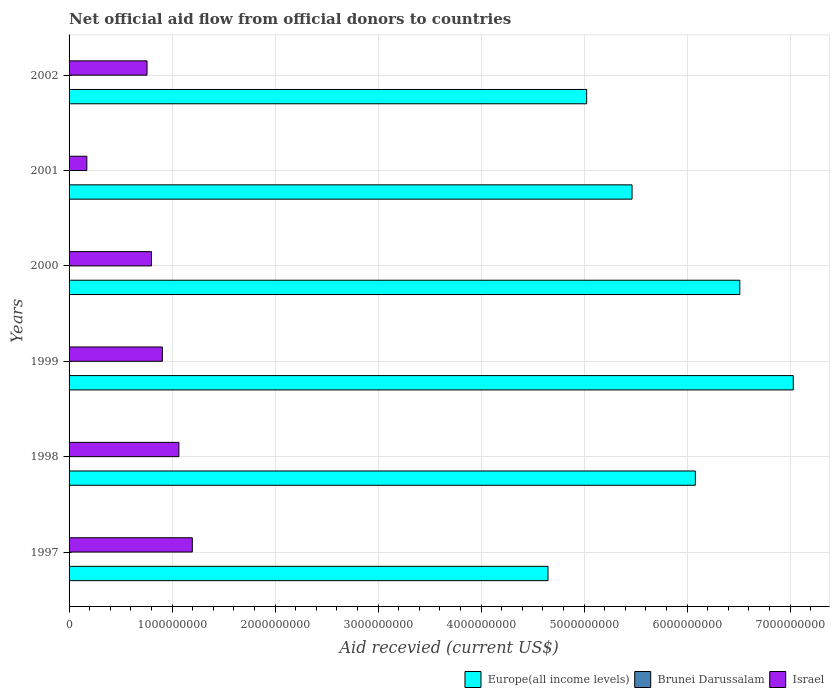How many different coloured bars are there?
Your response must be concise. 3. Are the number of bars per tick equal to the number of legend labels?
Ensure brevity in your answer.  No. Are the number of bars on each tick of the Y-axis equal?
Your answer should be very brief. No. How many bars are there on the 2nd tick from the top?
Your response must be concise. 3. What is the total aid received in Israel in 1999?
Offer a very short reply. 9.06e+08. Across all years, what is the maximum total aid received in Israel?
Make the answer very short. 1.20e+09. What is the total total aid received in Europe(all income levels) in the graph?
Offer a very short reply. 3.48e+1. What is the difference between the total aid received in Europe(all income levels) in 1997 and that in 1998?
Provide a succinct answer. -1.43e+09. What is the difference between the total aid received in Europe(all income levels) in 2000 and the total aid received in Brunei Darussalam in 1998?
Provide a short and direct response. 6.51e+09. What is the average total aid received in Europe(all income levels) per year?
Give a very brief answer. 5.79e+09. In the year 2002, what is the difference between the total aid received in Europe(all income levels) and total aid received in Israel?
Ensure brevity in your answer.  4.27e+09. What is the ratio of the total aid received in Israel in 2001 to that in 2002?
Provide a short and direct response. 0.23. Is the total aid received in Europe(all income levels) in 1998 less than that in 2002?
Ensure brevity in your answer.  No. What is the difference between the highest and the lowest total aid received in Europe(all income levels)?
Ensure brevity in your answer.  2.38e+09. Is it the case that in every year, the sum of the total aid received in Brunei Darussalam and total aid received in Europe(all income levels) is greater than the total aid received in Israel?
Keep it short and to the point. Yes. Are all the bars in the graph horizontal?
Your answer should be compact. Yes. How many years are there in the graph?
Keep it short and to the point. 6. Does the graph contain any zero values?
Make the answer very short. Yes. Where does the legend appear in the graph?
Keep it short and to the point. Bottom right. How many legend labels are there?
Keep it short and to the point. 3. What is the title of the graph?
Give a very brief answer. Net official aid flow from official donors to countries. Does "Romania" appear as one of the legend labels in the graph?
Give a very brief answer. No. What is the label or title of the X-axis?
Offer a very short reply. Aid recevied (current US$). What is the Aid recevied (current US$) in Europe(all income levels) in 1997?
Provide a succinct answer. 4.65e+09. What is the Aid recevied (current US$) of Brunei Darussalam in 1997?
Ensure brevity in your answer.  3.80e+05. What is the Aid recevied (current US$) in Israel in 1997?
Make the answer very short. 1.20e+09. What is the Aid recevied (current US$) of Europe(all income levels) in 1998?
Your answer should be very brief. 6.08e+09. What is the Aid recevied (current US$) of Brunei Darussalam in 1998?
Ensure brevity in your answer.  3.30e+05. What is the Aid recevied (current US$) of Israel in 1998?
Keep it short and to the point. 1.07e+09. What is the Aid recevied (current US$) of Europe(all income levels) in 1999?
Offer a very short reply. 7.03e+09. What is the Aid recevied (current US$) in Brunei Darussalam in 1999?
Your answer should be very brief. 1.43e+06. What is the Aid recevied (current US$) in Israel in 1999?
Provide a succinct answer. 9.06e+08. What is the Aid recevied (current US$) in Europe(all income levels) in 2000?
Offer a very short reply. 6.51e+09. What is the Aid recevied (current US$) in Brunei Darussalam in 2000?
Your answer should be compact. 6.30e+05. What is the Aid recevied (current US$) of Israel in 2000?
Offer a terse response. 8.00e+08. What is the Aid recevied (current US$) in Europe(all income levels) in 2001?
Your answer should be very brief. 5.47e+09. What is the Aid recevied (current US$) in Brunei Darussalam in 2001?
Keep it short and to the point. 3.50e+05. What is the Aid recevied (current US$) of Israel in 2001?
Ensure brevity in your answer.  1.72e+08. What is the Aid recevied (current US$) in Europe(all income levels) in 2002?
Provide a short and direct response. 5.02e+09. What is the Aid recevied (current US$) of Israel in 2002?
Make the answer very short. 7.57e+08. Across all years, what is the maximum Aid recevied (current US$) of Europe(all income levels)?
Give a very brief answer. 7.03e+09. Across all years, what is the maximum Aid recevied (current US$) of Brunei Darussalam?
Your answer should be compact. 1.43e+06. Across all years, what is the maximum Aid recevied (current US$) of Israel?
Offer a terse response. 1.20e+09. Across all years, what is the minimum Aid recevied (current US$) in Europe(all income levels)?
Offer a very short reply. 4.65e+09. Across all years, what is the minimum Aid recevied (current US$) in Israel?
Keep it short and to the point. 1.72e+08. What is the total Aid recevied (current US$) in Europe(all income levels) in the graph?
Ensure brevity in your answer.  3.48e+1. What is the total Aid recevied (current US$) in Brunei Darussalam in the graph?
Your answer should be very brief. 3.12e+06. What is the total Aid recevied (current US$) in Israel in the graph?
Offer a terse response. 4.90e+09. What is the difference between the Aid recevied (current US$) of Europe(all income levels) in 1997 and that in 1998?
Provide a short and direct response. -1.43e+09. What is the difference between the Aid recevied (current US$) of Brunei Darussalam in 1997 and that in 1998?
Give a very brief answer. 5.00e+04. What is the difference between the Aid recevied (current US$) of Israel in 1997 and that in 1998?
Offer a terse response. 1.30e+08. What is the difference between the Aid recevied (current US$) of Europe(all income levels) in 1997 and that in 1999?
Give a very brief answer. -2.38e+09. What is the difference between the Aid recevied (current US$) of Brunei Darussalam in 1997 and that in 1999?
Keep it short and to the point. -1.05e+06. What is the difference between the Aid recevied (current US$) in Israel in 1997 and that in 1999?
Offer a terse response. 2.91e+08. What is the difference between the Aid recevied (current US$) of Europe(all income levels) in 1997 and that in 2000?
Ensure brevity in your answer.  -1.86e+09. What is the difference between the Aid recevied (current US$) of Israel in 1997 and that in 2000?
Make the answer very short. 3.96e+08. What is the difference between the Aid recevied (current US$) in Europe(all income levels) in 1997 and that in 2001?
Offer a very short reply. -8.16e+08. What is the difference between the Aid recevied (current US$) in Brunei Darussalam in 1997 and that in 2001?
Your answer should be very brief. 3.00e+04. What is the difference between the Aid recevied (current US$) of Israel in 1997 and that in 2001?
Your answer should be compact. 1.02e+09. What is the difference between the Aid recevied (current US$) of Europe(all income levels) in 1997 and that in 2002?
Provide a succinct answer. -3.75e+08. What is the difference between the Aid recevied (current US$) in Israel in 1997 and that in 2002?
Keep it short and to the point. 4.39e+08. What is the difference between the Aid recevied (current US$) in Europe(all income levels) in 1998 and that in 1999?
Your response must be concise. -9.51e+08. What is the difference between the Aid recevied (current US$) in Brunei Darussalam in 1998 and that in 1999?
Make the answer very short. -1.10e+06. What is the difference between the Aid recevied (current US$) of Israel in 1998 and that in 1999?
Offer a terse response. 1.60e+08. What is the difference between the Aid recevied (current US$) in Europe(all income levels) in 1998 and that in 2000?
Offer a terse response. -4.32e+08. What is the difference between the Aid recevied (current US$) in Israel in 1998 and that in 2000?
Ensure brevity in your answer.  2.66e+08. What is the difference between the Aid recevied (current US$) in Europe(all income levels) in 1998 and that in 2001?
Provide a short and direct response. 6.14e+08. What is the difference between the Aid recevied (current US$) in Israel in 1998 and that in 2001?
Your answer should be compact. 8.94e+08. What is the difference between the Aid recevied (current US$) of Europe(all income levels) in 1998 and that in 2002?
Provide a short and direct response. 1.05e+09. What is the difference between the Aid recevied (current US$) of Israel in 1998 and that in 2002?
Ensure brevity in your answer.  3.09e+08. What is the difference between the Aid recevied (current US$) of Europe(all income levels) in 1999 and that in 2000?
Provide a succinct answer. 5.19e+08. What is the difference between the Aid recevied (current US$) in Israel in 1999 and that in 2000?
Offer a very short reply. 1.06e+08. What is the difference between the Aid recevied (current US$) in Europe(all income levels) in 1999 and that in 2001?
Your response must be concise. 1.57e+09. What is the difference between the Aid recevied (current US$) of Brunei Darussalam in 1999 and that in 2001?
Provide a succinct answer. 1.08e+06. What is the difference between the Aid recevied (current US$) of Israel in 1999 and that in 2001?
Your response must be concise. 7.33e+08. What is the difference between the Aid recevied (current US$) of Europe(all income levels) in 1999 and that in 2002?
Your answer should be compact. 2.01e+09. What is the difference between the Aid recevied (current US$) in Israel in 1999 and that in 2002?
Your answer should be compact. 1.49e+08. What is the difference between the Aid recevied (current US$) of Europe(all income levels) in 2000 and that in 2001?
Provide a short and direct response. 1.05e+09. What is the difference between the Aid recevied (current US$) of Brunei Darussalam in 2000 and that in 2001?
Your answer should be very brief. 2.80e+05. What is the difference between the Aid recevied (current US$) in Israel in 2000 and that in 2001?
Your answer should be very brief. 6.28e+08. What is the difference between the Aid recevied (current US$) in Europe(all income levels) in 2000 and that in 2002?
Provide a short and direct response. 1.49e+09. What is the difference between the Aid recevied (current US$) of Israel in 2000 and that in 2002?
Offer a terse response. 4.31e+07. What is the difference between the Aid recevied (current US$) of Europe(all income levels) in 2001 and that in 2002?
Your response must be concise. 4.41e+08. What is the difference between the Aid recevied (current US$) in Israel in 2001 and that in 2002?
Provide a short and direct response. -5.85e+08. What is the difference between the Aid recevied (current US$) in Europe(all income levels) in 1997 and the Aid recevied (current US$) in Brunei Darussalam in 1998?
Provide a short and direct response. 4.65e+09. What is the difference between the Aid recevied (current US$) in Europe(all income levels) in 1997 and the Aid recevied (current US$) in Israel in 1998?
Keep it short and to the point. 3.58e+09. What is the difference between the Aid recevied (current US$) in Brunei Darussalam in 1997 and the Aid recevied (current US$) in Israel in 1998?
Offer a very short reply. -1.07e+09. What is the difference between the Aid recevied (current US$) of Europe(all income levels) in 1997 and the Aid recevied (current US$) of Brunei Darussalam in 1999?
Provide a succinct answer. 4.65e+09. What is the difference between the Aid recevied (current US$) of Europe(all income levels) in 1997 and the Aid recevied (current US$) of Israel in 1999?
Your answer should be compact. 3.74e+09. What is the difference between the Aid recevied (current US$) of Brunei Darussalam in 1997 and the Aid recevied (current US$) of Israel in 1999?
Give a very brief answer. -9.05e+08. What is the difference between the Aid recevied (current US$) of Europe(all income levels) in 1997 and the Aid recevied (current US$) of Brunei Darussalam in 2000?
Provide a succinct answer. 4.65e+09. What is the difference between the Aid recevied (current US$) of Europe(all income levels) in 1997 and the Aid recevied (current US$) of Israel in 2000?
Offer a very short reply. 3.85e+09. What is the difference between the Aid recevied (current US$) of Brunei Darussalam in 1997 and the Aid recevied (current US$) of Israel in 2000?
Your answer should be very brief. -8.00e+08. What is the difference between the Aid recevied (current US$) of Europe(all income levels) in 1997 and the Aid recevied (current US$) of Brunei Darussalam in 2001?
Provide a succinct answer. 4.65e+09. What is the difference between the Aid recevied (current US$) in Europe(all income levels) in 1997 and the Aid recevied (current US$) in Israel in 2001?
Offer a terse response. 4.48e+09. What is the difference between the Aid recevied (current US$) of Brunei Darussalam in 1997 and the Aid recevied (current US$) of Israel in 2001?
Make the answer very short. -1.72e+08. What is the difference between the Aid recevied (current US$) in Europe(all income levels) in 1997 and the Aid recevied (current US$) in Israel in 2002?
Provide a succinct answer. 3.89e+09. What is the difference between the Aid recevied (current US$) of Brunei Darussalam in 1997 and the Aid recevied (current US$) of Israel in 2002?
Make the answer very short. -7.56e+08. What is the difference between the Aid recevied (current US$) of Europe(all income levels) in 1998 and the Aid recevied (current US$) of Brunei Darussalam in 1999?
Your response must be concise. 6.08e+09. What is the difference between the Aid recevied (current US$) in Europe(all income levels) in 1998 and the Aid recevied (current US$) in Israel in 1999?
Provide a short and direct response. 5.17e+09. What is the difference between the Aid recevied (current US$) in Brunei Darussalam in 1998 and the Aid recevied (current US$) in Israel in 1999?
Keep it short and to the point. -9.05e+08. What is the difference between the Aid recevied (current US$) in Europe(all income levels) in 1998 and the Aid recevied (current US$) in Brunei Darussalam in 2000?
Keep it short and to the point. 6.08e+09. What is the difference between the Aid recevied (current US$) of Europe(all income levels) in 1998 and the Aid recevied (current US$) of Israel in 2000?
Offer a very short reply. 5.28e+09. What is the difference between the Aid recevied (current US$) of Brunei Darussalam in 1998 and the Aid recevied (current US$) of Israel in 2000?
Provide a succinct answer. -8.00e+08. What is the difference between the Aid recevied (current US$) in Europe(all income levels) in 1998 and the Aid recevied (current US$) in Brunei Darussalam in 2001?
Provide a short and direct response. 6.08e+09. What is the difference between the Aid recevied (current US$) of Europe(all income levels) in 1998 and the Aid recevied (current US$) of Israel in 2001?
Make the answer very short. 5.91e+09. What is the difference between the Aid recevied (current US$) in Brunei Darussalam in 1998 and the Aid recevied (current US$) in Israel in 2001?
Your response must be concise. -1.72e+08. What is the difference between the Aid recevied (current US$) in Europe(all income levels) in 1998 and the Aid recevied (current US$) in Israel in 2002?
Your answer should be very brief. 5.32e+09. What is the difference between the Aid recevied (current US$) of Brunei Darussalam in 1998 and the Aid recevied (current US$) of Israel in 2002?
Make the answer very short. -7.57e+08. What is the difference between the Aid recevied (current US$) of Europe(all income levels) in 1999 and the Aid recevied (current US$) of Brunei Darussalam in 2000?
Offer a very short reply. 7.03e+09. What is the difference between the Aid recevied (current US$) of Europe(all income levels) in 1999 and the Aid recevied (current US$) of Israel in 2000?
Keep it short and to the point. 6.23e+09. What is the difference between the Aid recevied (current US$) in Brunei Darussalam in 1999 and the Aid recevied (current US$) in Israel in 2000?
Your answer should be very brief. -7.99e+08. What is the difference between the Aid recevied (current US$) of Europe(all income levels) in 1999 and the Aid recevied (current US$) of Brunei Darussalam in 2001?
Ensure brevity in your answer.  7.03e+09. What is the difference between the Aid recevied (current US$) of Europe(all income levels) in 1999 and the Aid recevied (current US$) of Israel in 2001?
Ensure brevity in your answer.  6.86e+09. What is the difference between the Aid recevied (current US$) in Brunei Darussalam in 1999 and the Aid recevied (current US$) in Israel in 2001?
Offer a terse response. -1.71e+08. What is the difference between the Aid recevied (current US$) of Europe(all income levels) in 1999 and the Aid recevied (current US$) of Israel in 2002?
Your response must be concise. 6.27e+09. What is the difference between the Aid recevied (current US$) in Brunei Darussalam in 1999 and the Aid recevied (current US$) in Israel in 2002?
Provide a succinct answer. -7.55e+08. What is the difference between the Aid recevied (current US$) in Europe(all income levels) in 2000 and the Aid recevied (current US$) in Brunei Darussalam in 2001?
Provide a short and direct response. 6.51e+09. What is the difference between the Aid recevied (current US$) of Europe(all income levels) in 2000 and the Aid recevied (current US$) of Israel in 2001?
Provide a short and direct response. 6.34e+09. What is the difference between the Aid recevied (current US$) in Brunei Darussalam in 2000 and the Aid recevied (current US$) in Israel in 2001?
Keep it short and to the point. -1.72e+08. What is the difference between the Aid recevied (current US$) in Europe(all income levels) in 2000 and the Aid recevied (current US$) in Israel in 2002?
Ensure brevity in your answer.  5.75e+09. What is the difference between the Aid recevied (current US$) in Brunei Darussalam in 2000 and the Aid recevied (current US$) in Israel in 2002?
Ensure brevity in your answer.  -7.56e+08. What is the difference between the Aid recevied (current US$) in Europe(all income levels) in 2001 and the Aid recevied (current US$) in Israel in 2002?
Ensure brevity in your answer.  4.71e+09. What is the difference between the Aid recevied (current US$) of Brunei Darussalam in 2001 and the Aid recevied (current US$) of Israel in 2002?
Give a very brief answer. -7.57e+08. What is the average Aid recevied (current US$) in Europe(all income levels) per year?
Ensure brevity in your answer.  5.79e+09. What is the average Aid recevied (current US$) in Brunei Darussalam per year?
Your answer should be compact. 5.20e+05. What is the average Aid recevied (current US$) in Israel per year?
Offer a very short reply. 8.16e+08. In the year 1997, what is the difference between the Aid recevied (current US$) in Europe(all income levels) and Aid recevied (current US$) in Brunei Darussalam?
Give a very brief answer. 4.65e+09. In the year 1997, what is the difference between the Aid recevied (current US$) of Europe(all income levels) and Aid recevied (current US$) of Israel?
Offer a terse response. 3.45e+09. In the year 1997, what is the difference between the Aid recevied (current US$) of Brunei Darussalam and Aid recevied (current US$) of Israel?
Make the answer very short. -1.20e+09. In the year 1998, what is the difference between the Aid recevied (current US$) of Europe(all income levels) and Aid recevied (current US$) of Brunei Darussalam?
Your response must be concise. 6.08e+09. In the year 1998, what is the difference between the Aid recevied (current US$) in Europe(all income levels) and Aid recevied (current US$) in Israel?
Provide a short and direct response. 5.01e+09. In the year 1998, what is the difference between the Aid recevied (current US$) of Brunei Darussalam and Aid recevied (current US$) of Israel?
Give a very brief answer. -1.07e+09. In the year 1999, what is the difference between the Aid recevied (current US$) of Europe(all income levels) and Aid recevied (current US$) of Brunei Darussalam?
Offer a very short reply. 7.03e+09. In the year 1999, what is the difference between the Aid recevied (current US$) in Europe(all income levels) and Aid recevied (current US$) in Israel?
Provide a short and direct response. 6.12e+09. In the year 1999, what is the difference between the Aid recevied (current US$) of Brunei Darussalam and Aid recevied (current US$) of Israel?
Provide a succinct answer. -9.04e+08. In the year 2000, what is the difference between the Aid recevied (current US$) in Europe(all income levels) and Aid recevied (current US$) in Brunei Darussalam?
Provide a short and direct response. 6.51e+09. In the year 2000, what is the difference between the Aid recevied (current US$) in Europe(all income levels) and Aid recevied (current US$) in Israel?
Your answer should be very brief. 5.71e+09. In the year 2000, what is the difference between the Aid recevied (current US$) of Brunei Darussalam and Aid recevied (current US$) of Israel?
Give a very brief answer. -7.99e+08. In the year 2001, what is the difference between the Aid recevied (current US$) in Europe(all income levels) and Aid recevied (current US$) in Brunei Darussalam?
Offer a very short reply. 5.46e+09. In the year 2001, what is the difference between the Aid recevied (current US$) of Europe(all income levels) and Aid recevied (current US$) of Israel?
Your response must be concise. 5.29e+09. In the year 2001, what is the difference between the Aid recevied (current US$) in Brunei Darussalam and Aid recevied (current US$) in Israel?
Give a very brief answer. -1.72e+08. In the year 2002, what is the difference between the Aid recevied (current US$) in Europe(all income levels) and Aid recevied (current US$) in Israel?
Your response must be concise. 4.27e+09. What is the ratio of the Aid recevied (current US$) of Europe(all income levels) in 1997 to that in 1998?
Make the answer very short. 0.76. What is the ratio of the Aid recevied (current US$) in Brunei Darussalam in 1997 to that in 1998?
Ensure brevity in your answer.  1.15. What is the ratio of the Aid recevied (current US$) of Israel in 1997 to that in 1998?
Offer a very short reply. 1.12. What is the ratio of the Aid recevied (current US$) in Europe(all income levels) in 1997 to that in 1999?
Provide a succinct answer. 0.66. What is the ratio of the Aid recevied (current US$) of Brunei Darussalam in 1997 to that in 1999?
Offer a very short reply. 0.27. What is the ratio of the Aid recevied (current US$) in Israel in 1997 to that in 1999?
Your response must be concise. 1.32. What is the ratio of the Aid recevied (current US$) of Europe(all income levels) in 1997 to that in 2000?
Keep it short and to the point. 0.71. What is the ratio of the Aid recevied (current US$) of Brunei Darussalam in 1997 to that in 2000?
Ensure brevity in your answer.  0.6. What is the ratio of the Aid recevied (current US$) of Israel in 1997 to that in 2000?
Ensure brevity in your answer.  1.5. What is the ratio of the Aid recevied (current US$) of Europe(all income levels) in 1997 to that in 2001?
Offer a very short reply. 0.85. What is the ratio of the Aid recevied (current US$) in Brunei Darussalam in 1997 to that in 2001?
Your answer should be very brief. 1.09. What is the ratio of the Aid recevied (current US$) of Israel in 1997 to that in 2001?
Make the answer very short. 6.94. What is the ratio of the Aid recevied (current US$) of Europe(all income levels) in 1997 to that in 2002?
Give a very brief answer. 0.93. What is the ratio of the Aid recevied (current US$) of Israel in 1997 to that in 2002?
Provide a short and direct response. 1.58. What is the ratio of the Aid recevied (current US$) in Europe(all income levels) in 1998 to that in 1999?
Your response must be concise. 0.86. What is the ratio of the Aid recevied (current US$) of Brunei Darussalam in 1998 to that in 1999?
Your answer should be compact. 0.23. What is the ratio of the Aid recevied (current US$) in Israel in 1998 to that in 1999?
Make the answer very short. 1.18. What is the ratio of the Aid recevied (current US$) in Europe(all income levels) in 1998 to that in 2000?
Your answer should be compact. 0.93. What is the ratio of the Aid recevied (current US$) of Brunei Darussalam in 1998 to that in 2000?
Offer a very short reply. 0.52. What is the ratio of the Aid recevied (current US$) of Israel in 1998 to that in 2000?
Keep it short and to the point. 1.33. What is the ratio of the Aid recevied (current US$) of Europe(all income levels) in 1998 to that in 2001?
Give a very brief answer. 1.11. What is the ratio of the Aid recevied (current US$) in Brunei Darussalam in 1998 to that in 2001?
Your answer should be compact. 0.94. What is the ratio of the Aid recevied (current US$) in Israel in 1998 to that in 2001?
Your response must be concise. 6.19. What is the ratio of the Aid recevied (current US$) of Europe(all income levels) in 1998 to that in 2002?
Ensure brevity in your answer.  1.21. What is the ratio of the Aid recevied (current US$) in Israel in 1998 to that in 2002?
Make the answer very short. 1.41. What is the ratio of the Aid recevied (current US$) in Europe(all income levels) in 1999 to that in 2000?
Provide a succinct answer. 1.08. What is the ratio of the Aid recevied (current US$) of Brunei Darussalam in 1999 to that in 2000?
Offer a terse response. 2.27. What is the ratio of the Aid recevied (current US$) of Israel in 1999 to that in 2000?
Provide a succinct answer. 1.13. What is the ratio of the Aid recevied (current US$) in Europe(all income levels) in 1999 to that in 2001?
Your response must be concise. 1.29. What is the ratio of the Aid recevied (current US$) in Brunei Darussalam in 1999 to that in 2001?
Ensure brevity in your answer.  4.09. What is the ratio of the Aid recevied (current US$) in Israel in 1999 to that in 2001?
Your answer should be very brief. 5.26. What is the ratio of the Aid recevied (current US$) of Europe(all income levels) in 1999 to that in 2002?
Your response must be concise. 1.4. What is the ratio of the Aid recevied (current US$) of Israel in 1999 to that in 2002?
Keep it short and to the point. 1.2. What is the ratio of the Aid recevied (current US$) of Europe(all income levels) in 2000 to that in 2001?
Offer a very short reply. 1.19. What is the ratio of the Aid recevied (current US$) in Brunei Darussalam in 2000 to that in 2001?
Your answer should be very brief. 1.8. What is the ratio of the Aid recevied (current US$) in Israel in 2000 to that in 2001?
Your answer should be very brief. 4.64. What is the ratio of the Aid recevied (current US$) of Europe(all income levels) in 2000 to that in 2002?
Keep it short and to the point. 1.3. What is the ratio of the Aid recevied (current US$) in Israel in 2000 to that in 2002?
Make the answer very short. 1.06. What is the ratio of the Aid recevied (current US$) of Europe(all income levels) in 2001 to that in 2002?
Give a very brief answer. 1.09. What is the ratio of the Aid recevied (current US$) of Israel in 2001 to that in 2002?
Provide a short and direct response. 0.23. What is the difference between the highest and the second highest Aid recevied (current US$) in Europe(all income levels)?
Provide a short and direct response. 5.19e+08. What is the difference between the highest and the second highest Aid recevied (current US$) in Brunei Darussalam?
Your answer should be compact. 8.00e+05. What is the difference between the highest and the second highest Aid recevied (current US$) in Israel?
Make the answer very short. 1.30e+08. What is the difference between the highest and the lowest Aid recevied (current US$) in Europe(all income levels)?
Give a very brief answer. 2.38e+09. What is the difference between the highest and the lowest Aid recevied (current US$) in Brunei Darussalam?
Your answer should be very brief. 1.43e+06. What is the difference between the highest and the lowest Aid recevied (current US$) in Israel?
Your answer should be very brief. 1.02e+09. 